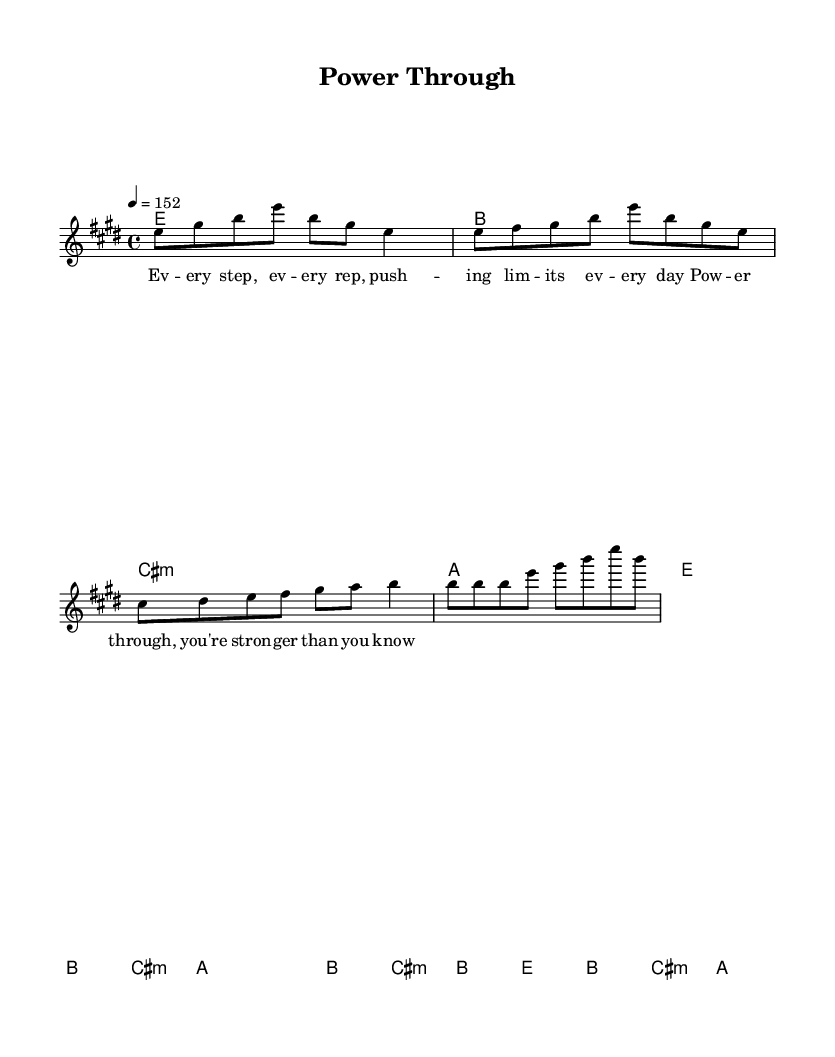What is the key signature of this music? The key signature of the music is indicated by the sharp signs in the key definition. In this case, it has four sharps, which corresponds to E major.
Answer: E major What is the time signature? The time signature is specified at the beginning of the piece, showing how many beats are in each measure. In this sheet music, it is noted as 4/4, meaning there are four beats per measure.
Answer: 4/4 What is the tempo marking? The tempo marking is provided using a quantifiable number, indicating the speed of the piece. Here, it is marked as 4 equals 152, meaning 152 beats per minute.
Answer: 152 What is the first chord in the melody? By examining the harmony section at the beginning, the first chord is indicated as E major. The corresponding note for the melody aligns with this chord.
Answer: E How many sections does the song contain? The structure of the song can be analyzed by looking at the different lyrical segments within the score. There are an intro, verse, pre-chorus, and chorus present, totaling four distinct sections.
Answer: Four Which lyrical section follows the verse? By reviewing the lyric arrangement in relation to the musical structure, the next section after the verse is the pre-chorus, as observed from the organization in the score.
Answer: Pre-chorus What is the main theme expressed in the lyrics of the chorus? The chorus lyrics emphasize a message of empowerment and resilience, focusing on the idea of strength and perseverance, which aligns with the overall theme of the song.
Answer: Strength 